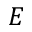Convert formula to latex. <formula><loc_0><loc_0><loc_500><loc_500>E</formula> 